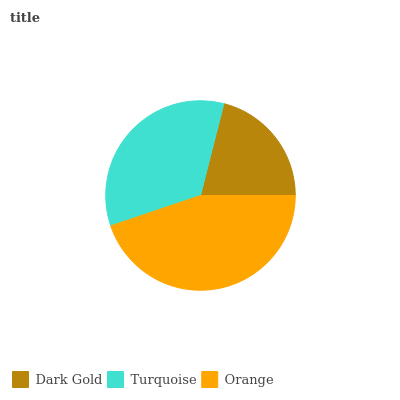Is Dark Gold the minimum?
Answer yes or no. Yes. Is Orange the maximum?
Answer yes or no. Yes. Is Turquoise the minimum?
Answer yes or no. No. Is Turquoise the maximum?
Answer yes or no. No. Is Turquoise greater than Dark Gold?
Answer yes or no. Yes. Is Dark Gold less than Turquoise?
Answer yes or no. Yes. Is Dark Gold greater than Turquoise?
Answer yes or no. No. Is Turquoise less than Dark Gold?
Answer yes or no. No. Is Turquoise the high median?
Answer yes or no. Yes. Is Turquoise the low median?
Answer yes or no. Yes. Is Orange the high median?
Answer yes or no. No. Is Dark Gold the low median?
Answer yes or no. No. 